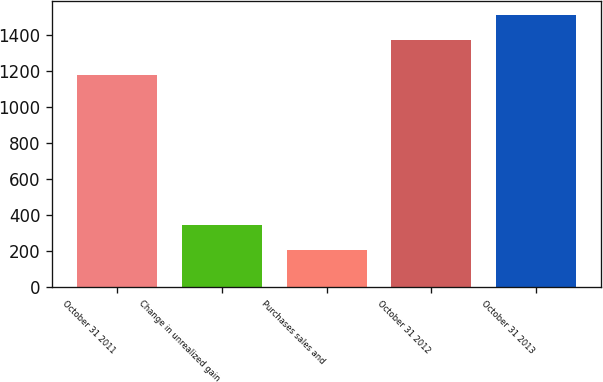Convert chart. <chart><loc_0><loc_0><loc_500><loc_500><bar_chart><fcel>October 31 2011<fcel>Change in unrealized gain<fcel>Purchases sales and<fcel>October 31 2012<fcel>October 31 2013<nl><fcel>1178<fcel>344.8<fcel>204.9<fcel>1373<fcel>1512.9<nl></chart> 